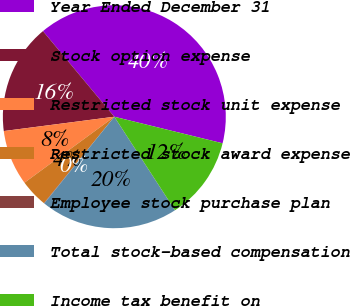Convert chart. <chart><loc_0><loc_0><loc_500><loc_500><pie_chart><fcel>Year Ended December 31<fcel>Stock option expense<fcel>Restricted stock unit expense<fcel>Restricted stock award expense<fcel>Employee stock purchase plan<fcel>Total stock-based compensation<fcel>Income tax benefit on<nl><fcel>39.89%<fcel>15.99%<fcel>8.03%<fcel>4.04%<fcel>0.06%<fcel>19.98%<fcel>12.01%<nl></chart> 